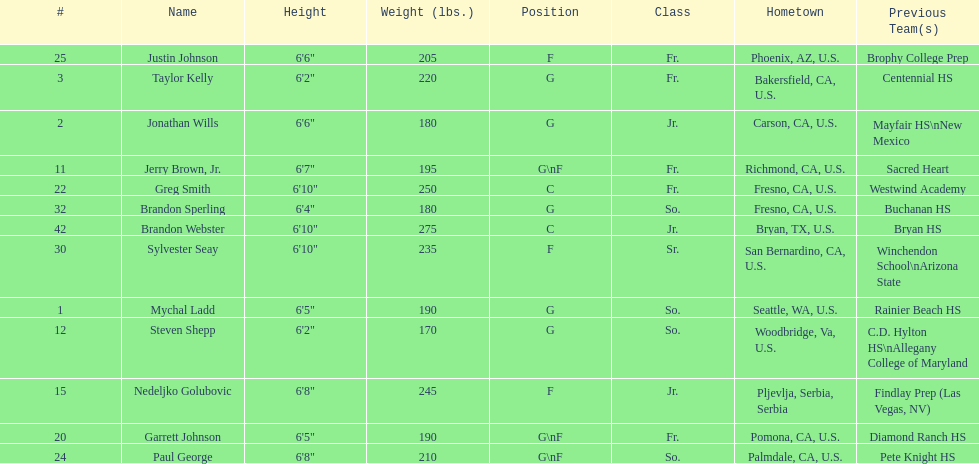Which player previously played for sacred heart? Jerry Brown, Jr. 